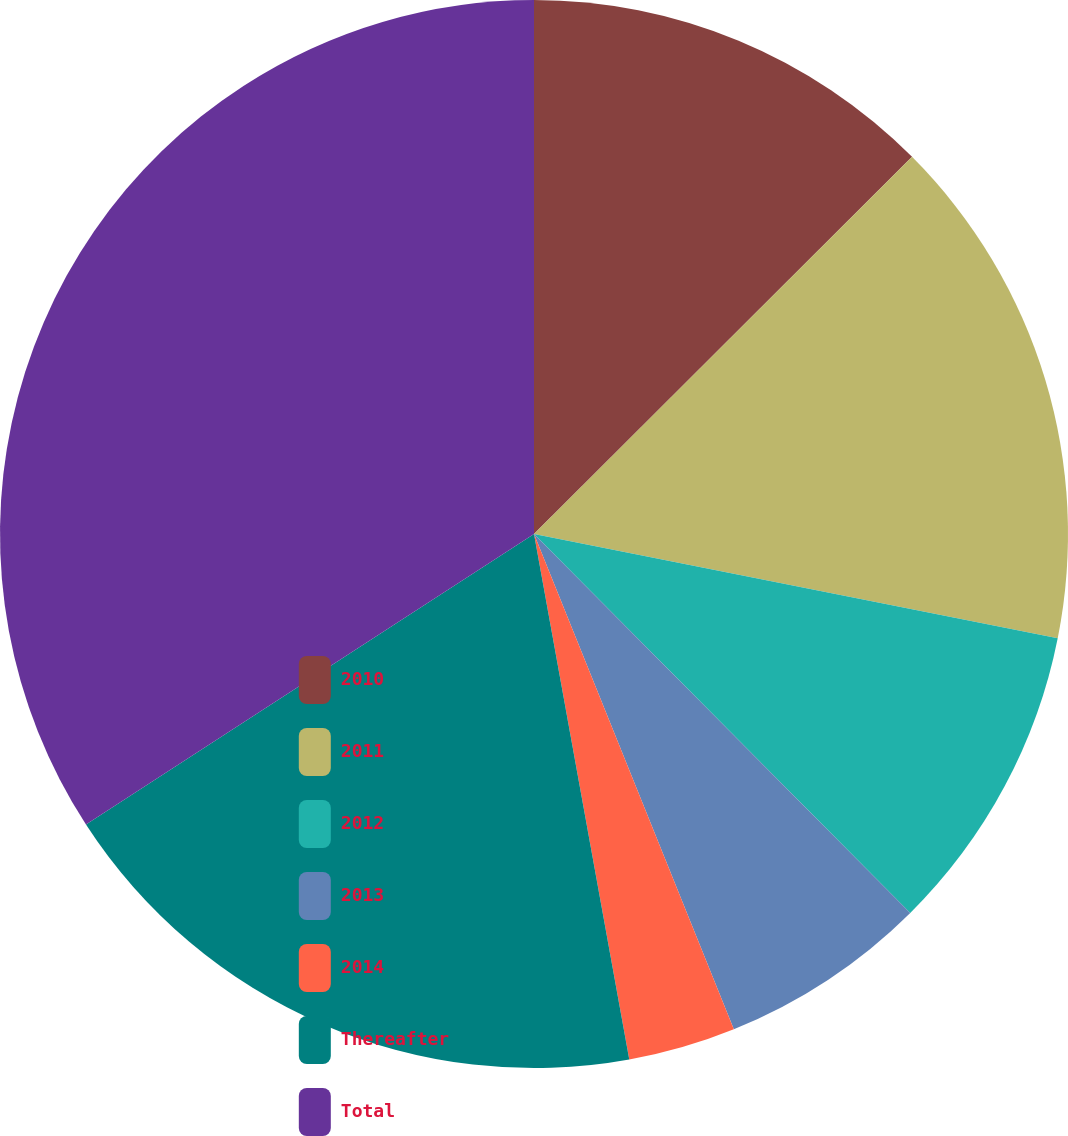Convert chart to OTSL. <chart><loc_0><loc_0><loc_500><loc_500><pie_chart><fcel>2010<fcel>2011<fcel>2012<fcel>2013<fcel>2014<fcel>Thereafter<fcel>Total<nl><fcel>12.52%<fcel>15.61%<fcel>9.43%<fcel>6.34%<fcel>3.25%<fcel>18.7%<fcel>34.16%<nl></chart> 